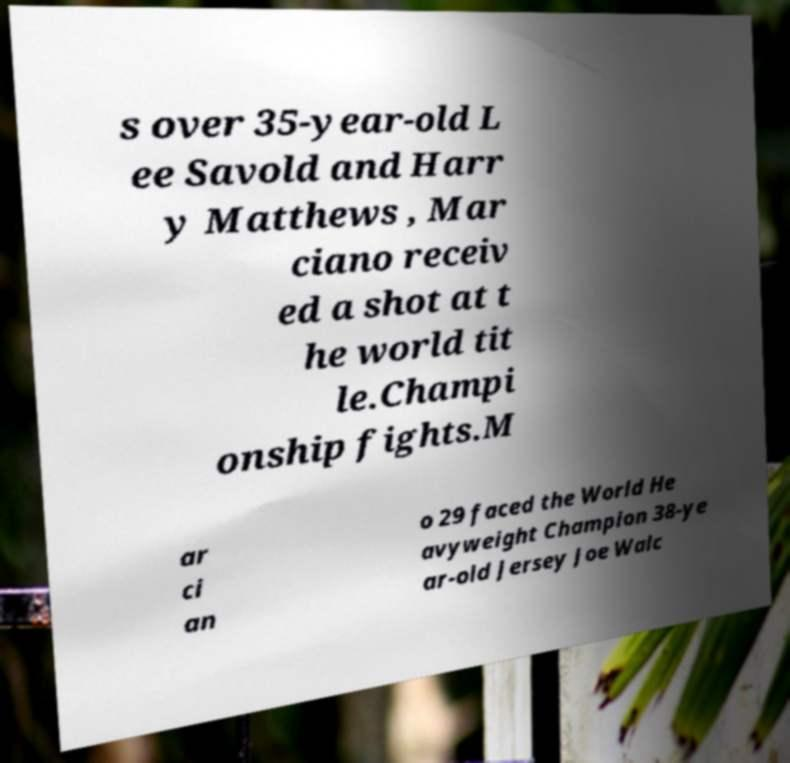Could you extract and type out the text from this image? s over 35-year-old L ee Savold and Harr y Matthews , Mar ciano receiv ed a shot at t he world tit le.Champi onship fights.M ar ci an o 29 faced the World He avyweight Champion 38-ye ar-old Jersey Joe Walc 